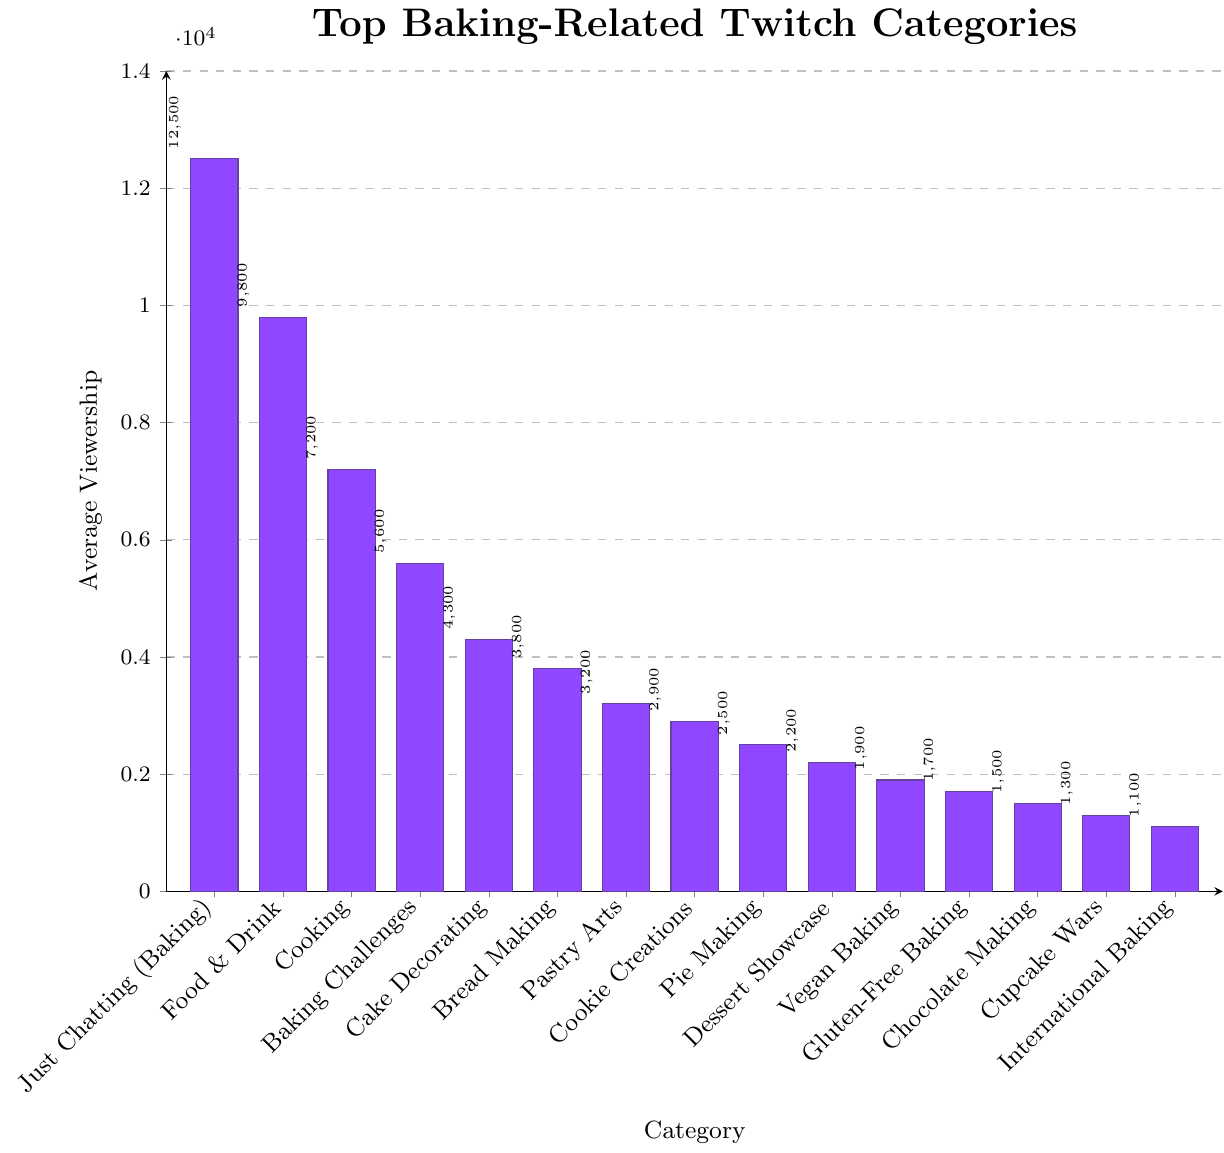What is the category with the highest average viewership? Identify the tallest bar in the figure, which represents the category with the highest average viewership. The 'Just Chatting (Baking)' bar is the tallest.
Answer: Just Chatting (Baking) How much higher is the average viewership of 'Just Chatting (Baking)' compared to 'Cake Decorating'? Find the average viewership of 'Just Chatting (Baking)' (12500) and 'Cake Decorating' (4300) and subtract the latter from the former: \(12500 - 4300 = 8200\).
Answer: 8200 What is the sum of the average viewership for 'Cooking', 'Baking Challenges', and 'Food & Drink'? Add the average viewership of 'Cooking' (7200), 'Baking Challenges' (5600), and 'Food & Drink' (9800): \(7200 + 5600 + 9800 = 22600\).
Answer: 22600 Which category has the lowest average viewership? Identify the shortest bar in the figure, which represents the category with the lowest average viewership. The 'International Baking' bar is the shortest.
Answer: International Baking Is the average viewership of 'Pastry Arts' greater than that of 'Cookie Creations'? Compare the average viewership of 'Pastry Arts' (3200) and 'Cookie Creations' (2900). Since 3200 is greater than 2900, the answer is 'yes'.
Answer: yes What is the difference between the average viewership of 'Bread Making' and 'Pie Making'? Subtract the average viewership of 'Pie Making' (2500) from 'Bread Making' (3800): \(3800 - 2500 = 1300\).
Answer: 1300 What is the average viewership of the top 5 categories? Find the sum of the average viewership of the top 5 categories: 'Just Chatting (Baking)' (12500), 'Food & Drink' (9800), 'Cooking' (7200), 'Baking Challenges' (5600), 'Cake Decorating' (4300). Sum is \(12500 + 9800 + 7200 + 5600 + 4300 = 39400\). Then divide by 5: \(39400 / 5 = 7880\).
Answer: 7880 How does 'Vegan Baking' viewership compare to 'Gluten-Free Baking'? Is it greater, less, or equal? Compare the average viewership of 'Vegan Baking' (1900) to 'Gluten-Free Baking' (1700). Since 1900 is greater than 1700, the answer is 'greater'.
Answer: greater Which categories have an average viewership over 5000? Identify the bars with heights above 5000. These categories are 'Just Chatting (Baking)' (12500), 'Food & Drink' (9800), 'Cooking' (7200), and 'Baking Challenges' (5600).
Answer: Just Chatting (Baking), Food & Drink, Cooking, Baking Challenges What is the combined viewership of 'Chocolate Making' and 'Cupcake Wars'? Add the average viewership of 'Chocolate Making' (1500) and 'Cupcake Wars' (1300): \(1500 + 1300 = 2800\).
Answer: 2800 